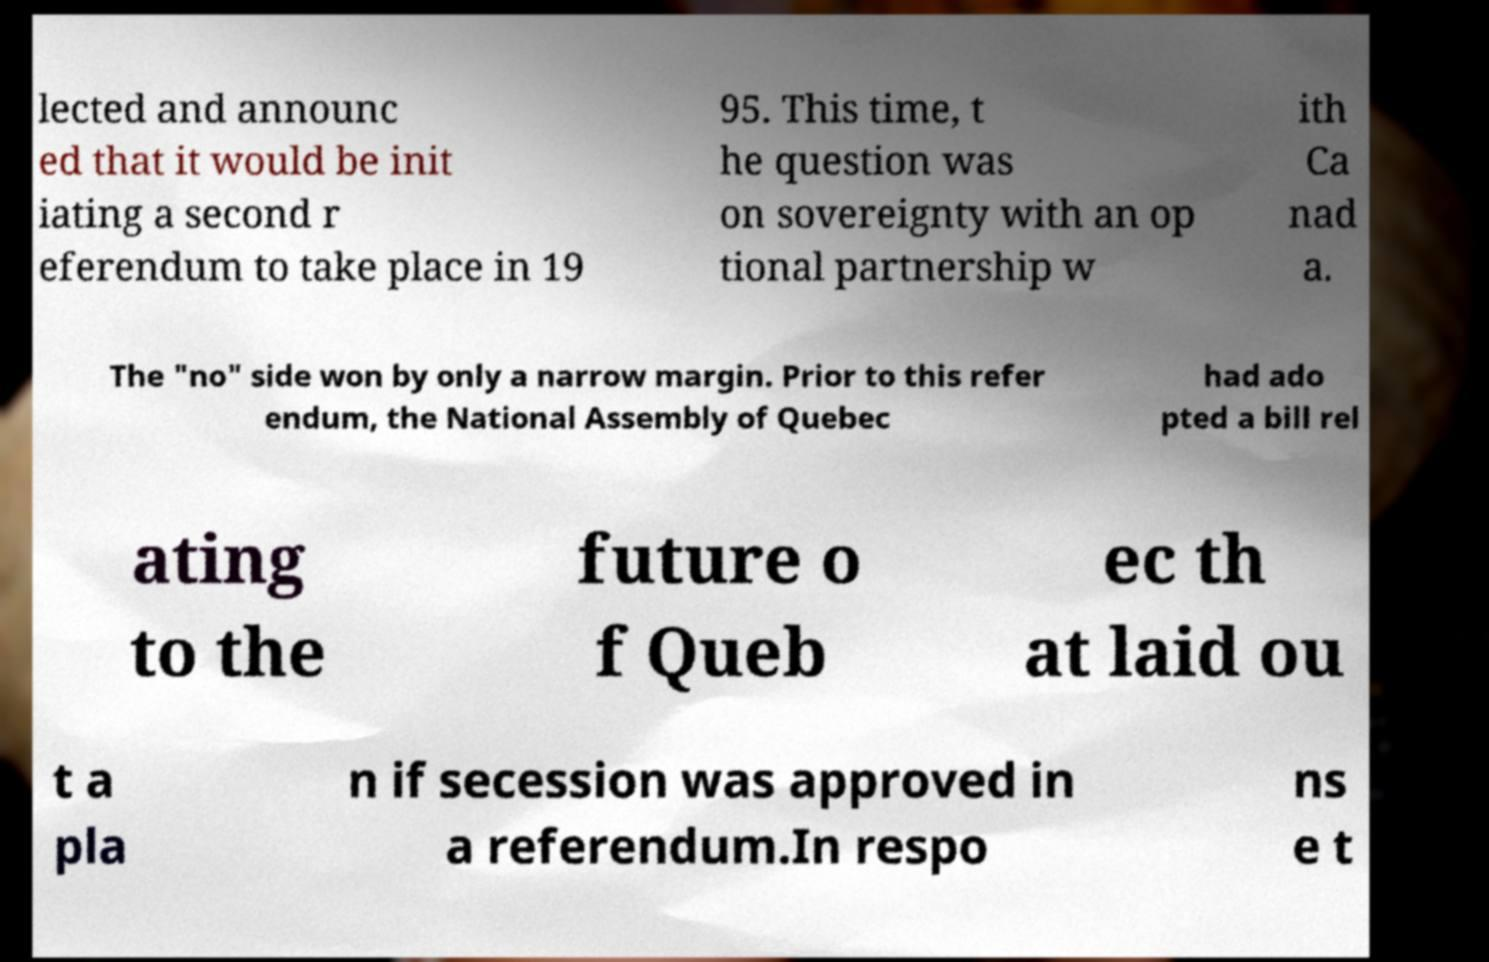For documentation purposes, I need the text within this image transcribed. Could you provide that? lected and announc ed that it would be init iating a second r eferendum to take place in 19 95. This time, t he question was on sovereignty with an op tional partnership w ith Ca nad a. The "no" side won by only a narrow margin. Prior to this refer endum, the National Assembly of Quebec had ado pted a bill rel ating to the future o f Queb ec th at laid ou t a pla n if secession was approved in a referendum.In respo ns e t 